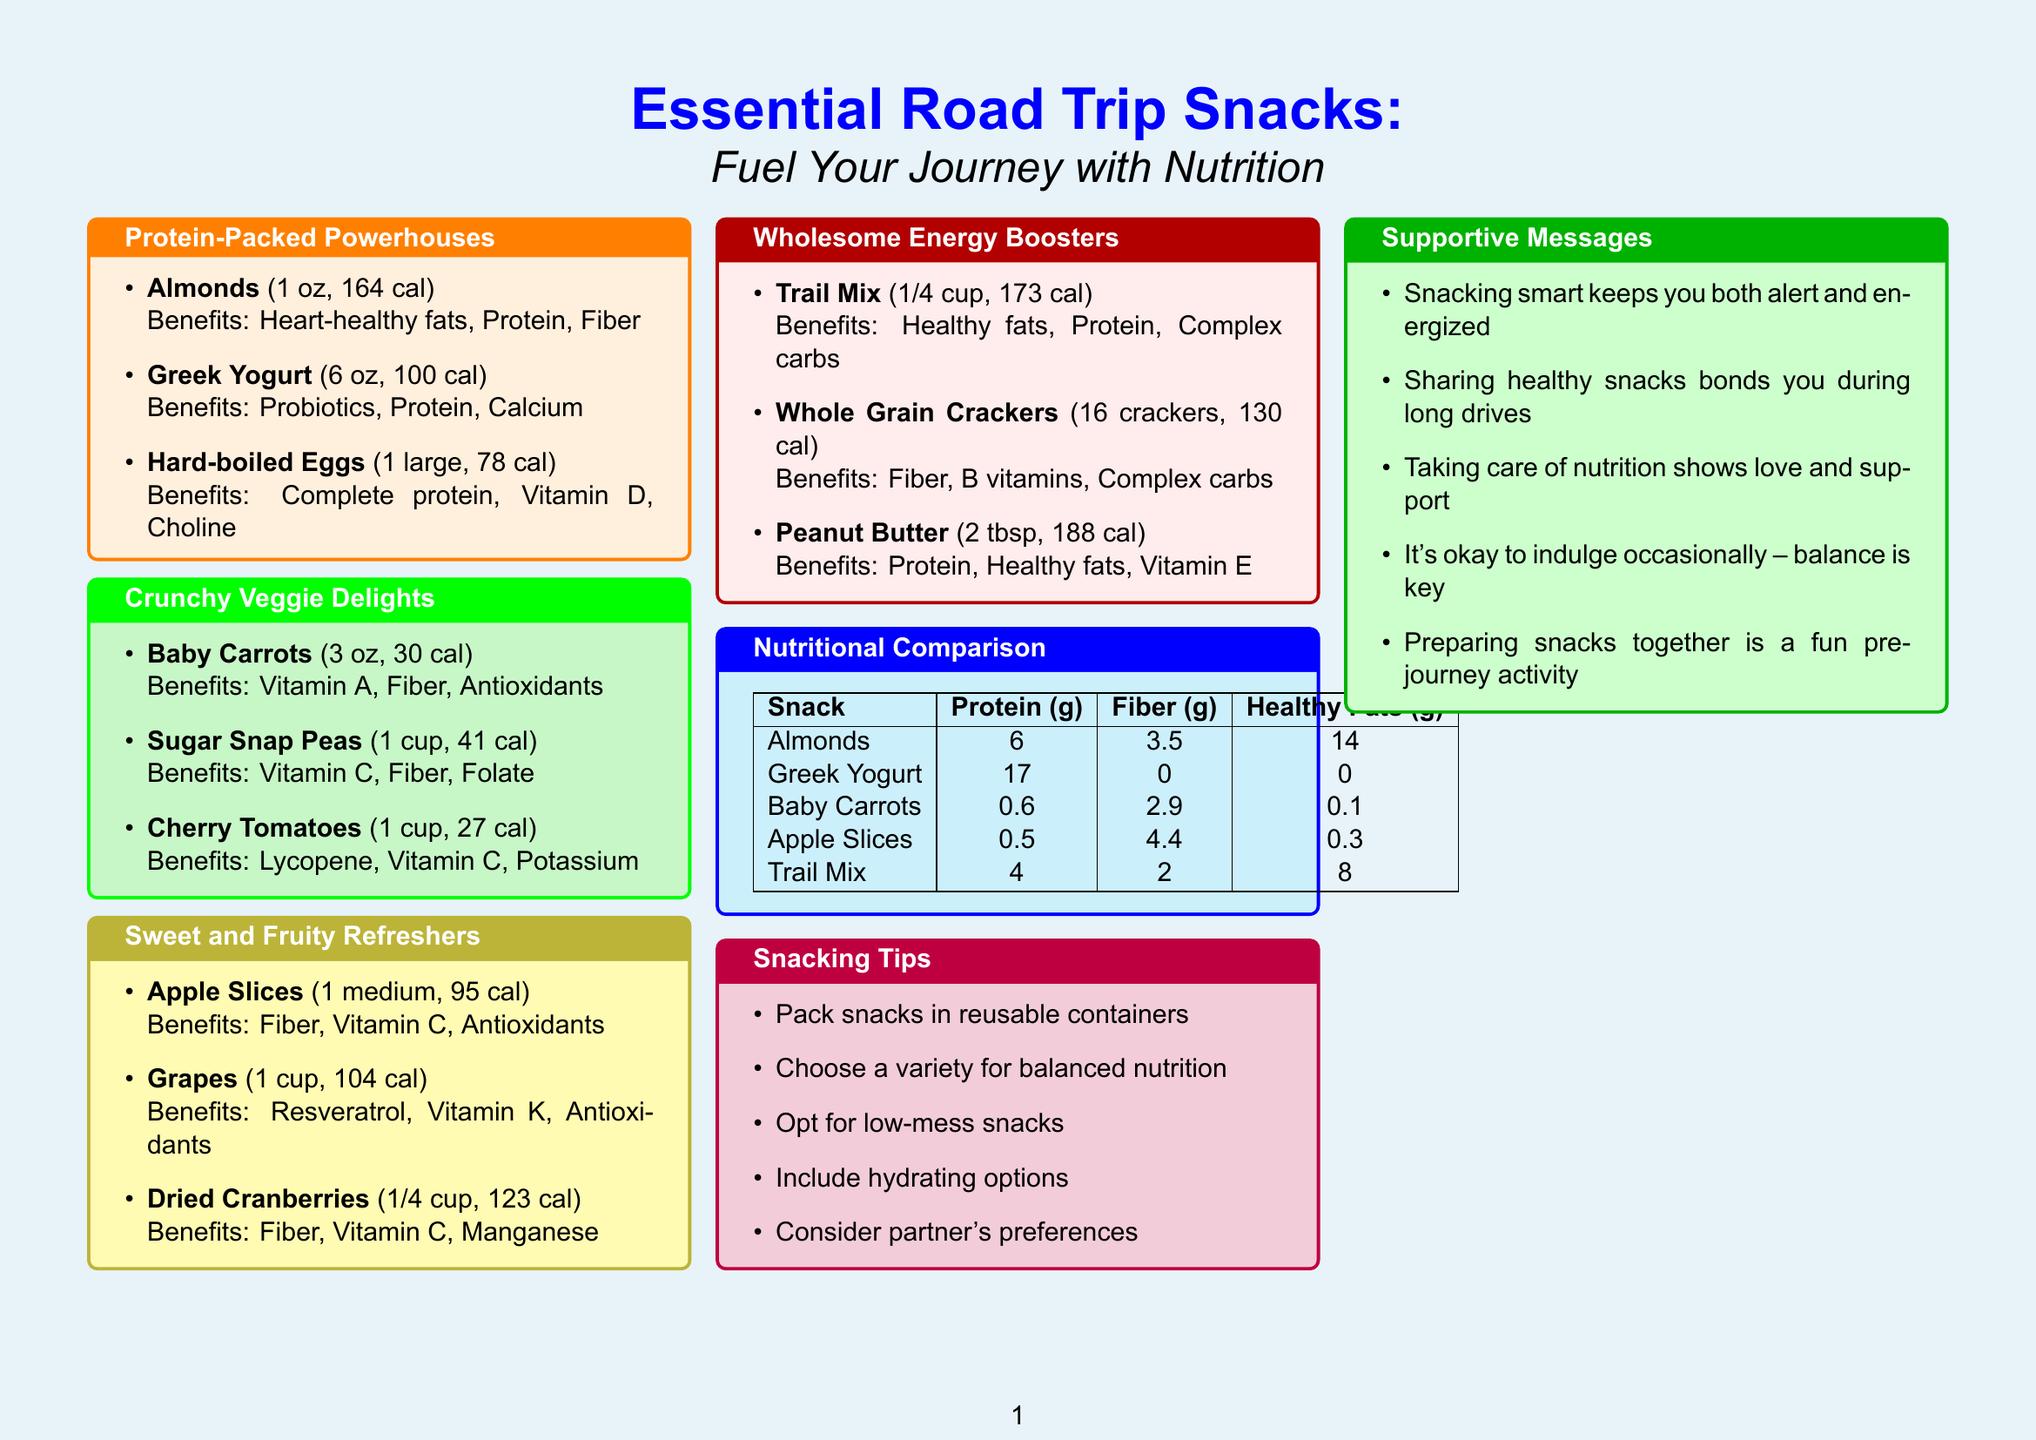What are the three categories of snacks highlighted? The document lists four categories of snacks: Protein-Packed Powerhouses, Crunchy Veggie Delights, Sweet and Fruity Refreshers, and Wholesome Energy Boosters.
Answer: Protein-Packed Powerhouses, Crunchy Veggie Delights, Sweet and Fruity Refreshers, Wholesome Energy Boosters How many calories are in Greek yogurt? The document specifies the calorie content of Greek yogurt under the protein-packed section.
Answer: 100 What benefits do almonds provide? The document indicates the benefits of almonds in the protein-packed section.
Answer: Heart-healthy fats, Protein, Fiber Which snack has the highest protein content according to the comparison chart? The nutritional comparison table shows the protein content for each snack.
Answer: Greek Yogurt What is a suggested tip for packing snacks? The document lists various tips for packing snacks in a specific section.
Answer: Pack snacks in reusable containers 